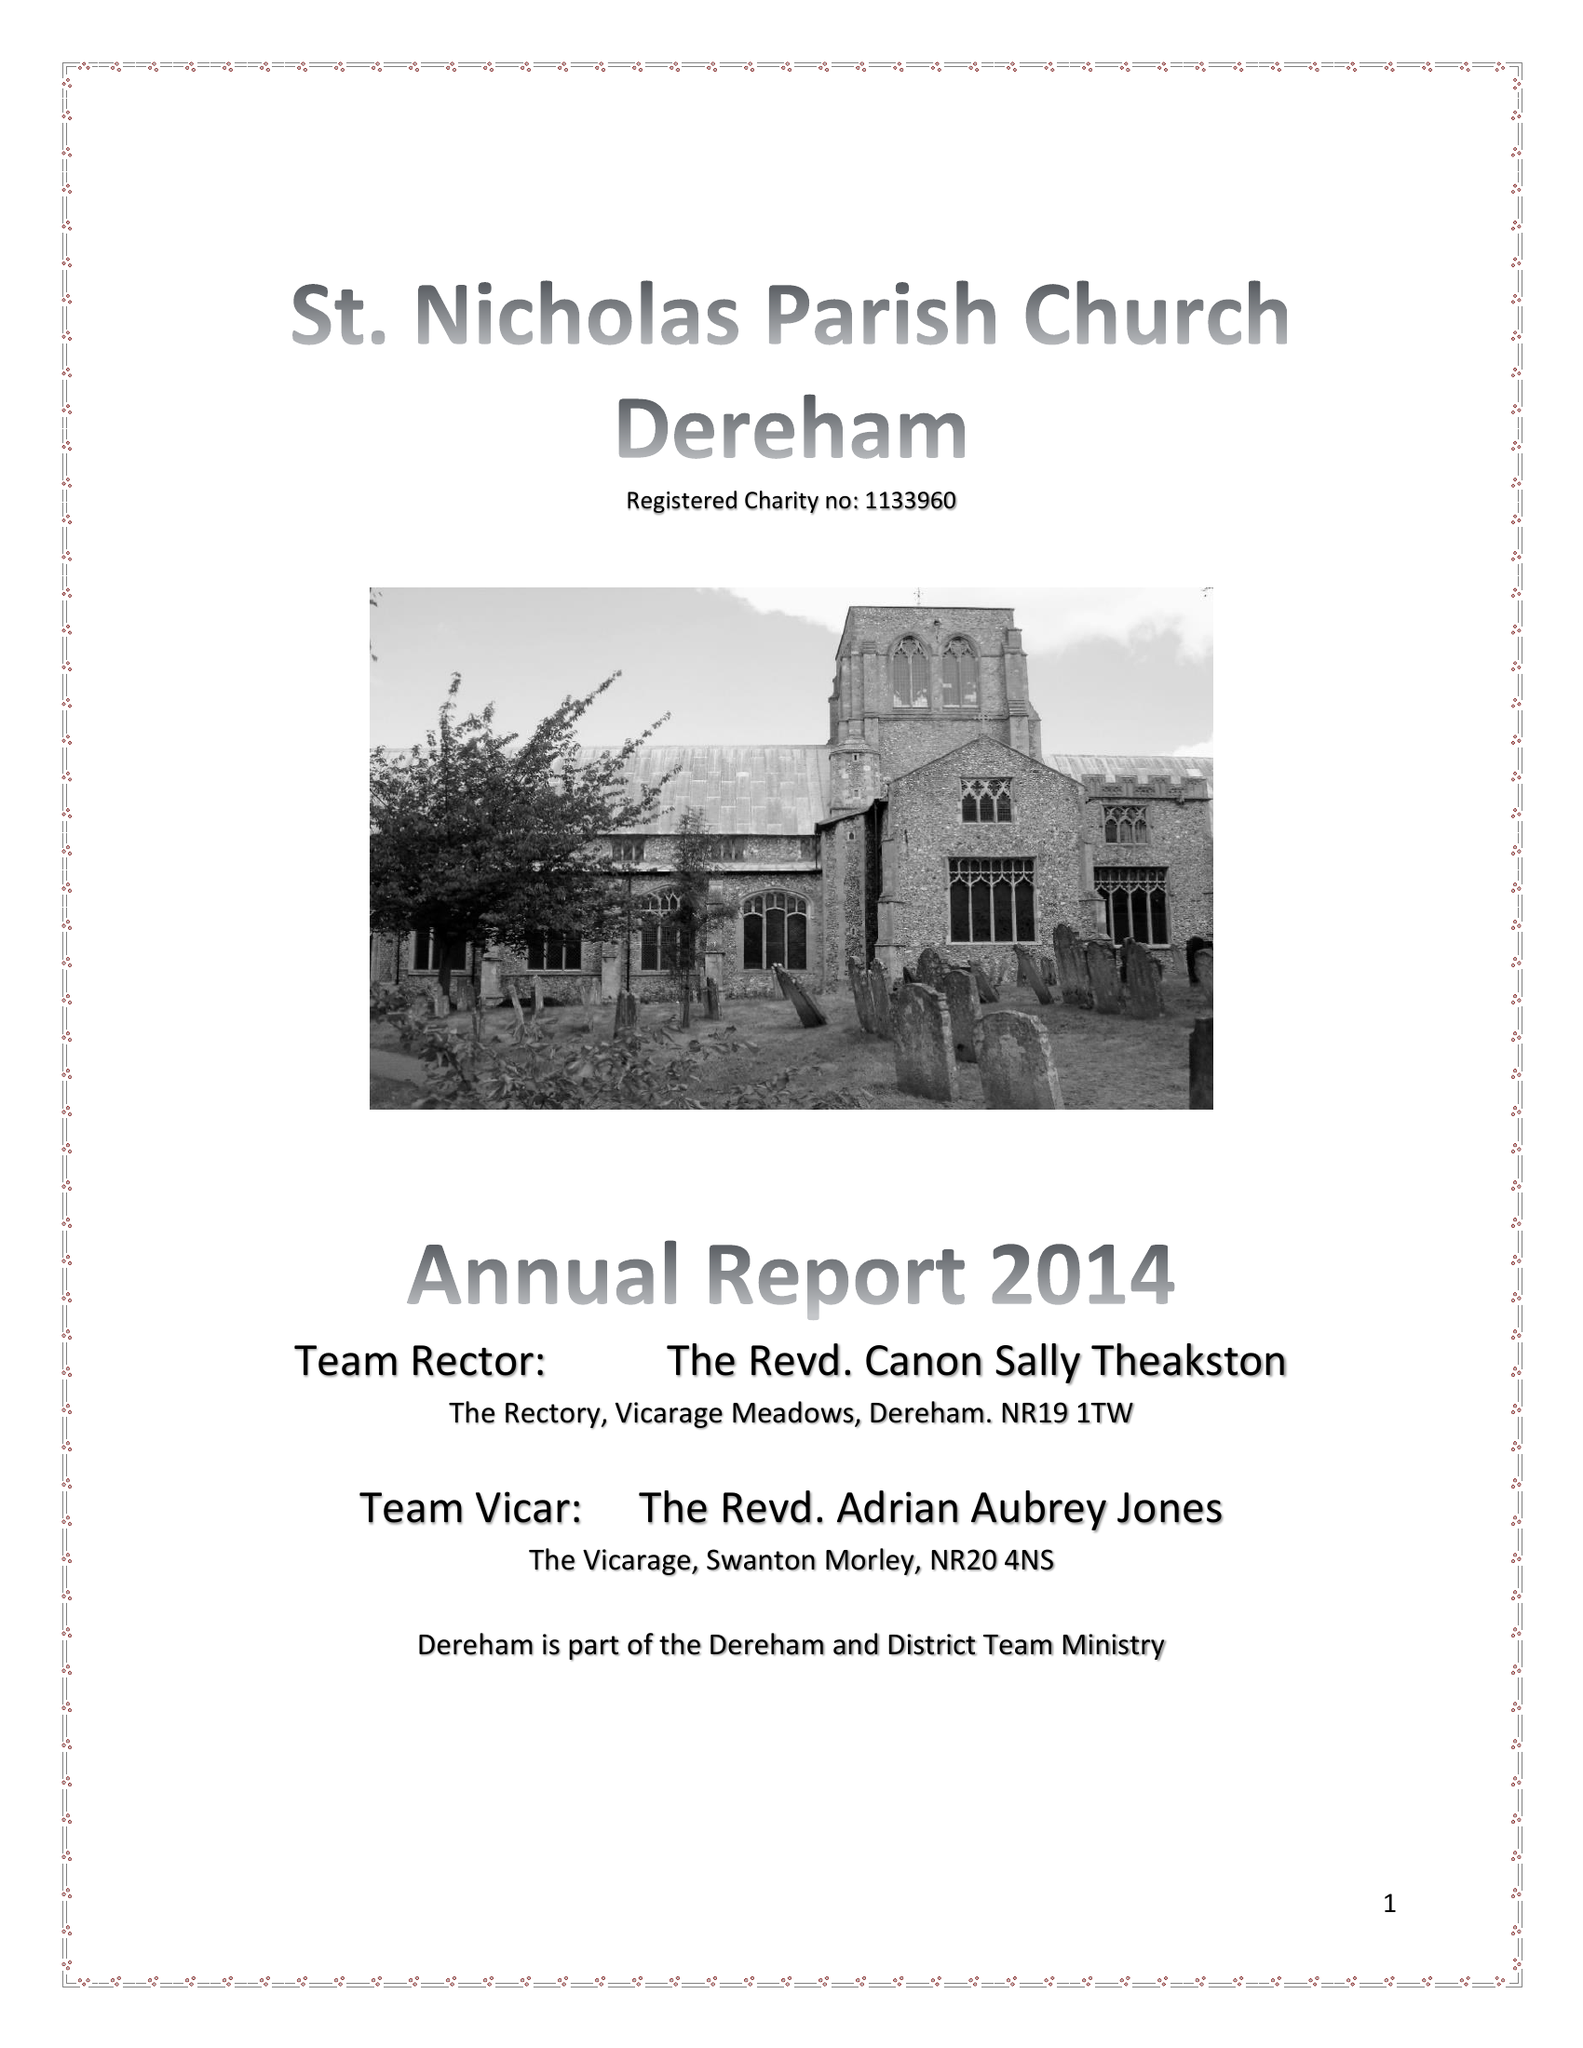What is the value for the charity_number?
Answer the question using a single word or phrase. 1133960 